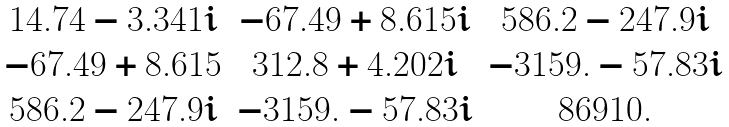Convert formula to latex. <formula><loc_0><loc_0><loc_500><loc_500>\begin{matrix} 1 4 . 7 4 - 3 . 3 4 1 i & - 6 7 . 4 9 + 8 . 6 1 5 i & 5 8 6 . 2 - 2 4 7 . 9 i \\ - 6 7 . 4 9 + 8 . 6 1 5 & 3 1 2 . 8 + 4 . 2 0 2 i & - 3 1 5 9 . - 5 7 . 8 3 i \\ 5 8 6 . 2 - 2 4 7 . 9 i & - 3 1 5 9 . - 5 7 . 8 3 i & 8 6 9 1 0 . \end{matrix}</formula> 